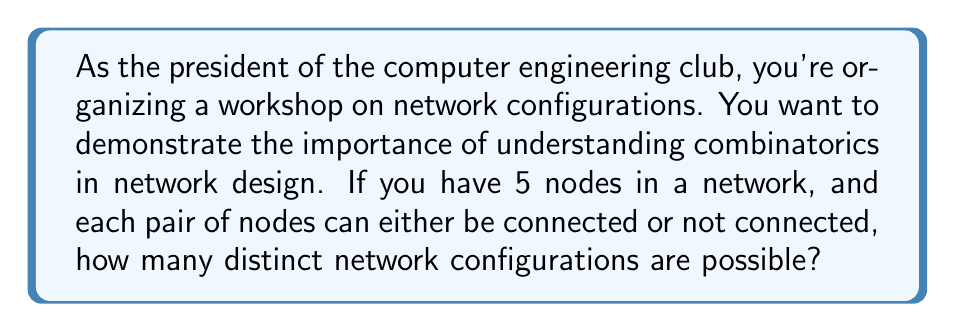Could you help me with this problem? Let's approach this step-by-step:

1) In a network with 5 nodes, we need to consider each possible connection between pairs of nodes.

2) The number of possible pairs of nodes is given by the combination formula:

   $$\binom{5}{2} = \frac{5!}{2!(5-2)!} = \frac{5 \cdot 4}{2 \cdot 1} = 10$$

3) For each of these 10 pairs, we have two choices: the nodes can be either connected or not connected.

4) This is equivalent to making 10 independent binary choices.

5) The total number of ways to make 10 independent binary choices is $2^{10}$.

6) Therefore, the number of distinct network configurations is $2^{10}$.

7) We can calculate this:

   $$2^{10} = 1024$$

This result shows that even with a relatively small number of nodes, the number of possible configurations grows exponentially, highlighting the complexity of network design and the importance of combinatorial thinking in computer engineering.
Answer: $2^{10} = 1024$ 